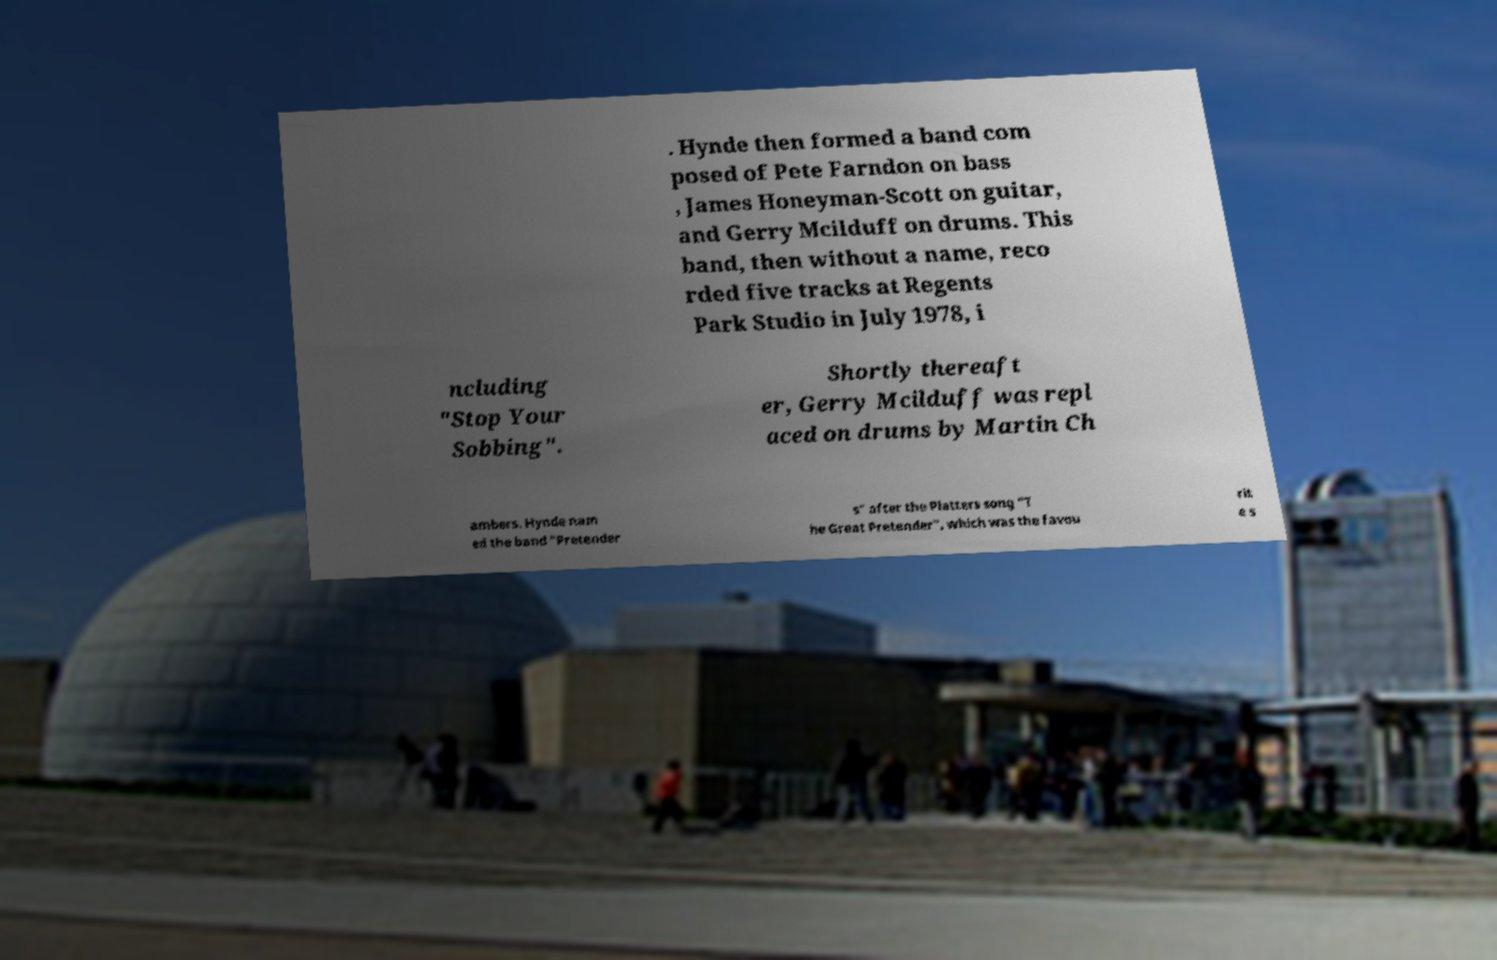There's text embedded in this image that I need extracted. Can you transcribe it verbatim? . Hynde then formed a band com posed of Pete Farndon on bass , James Honeyman-Scott on guitar, and Gerry Mcilduff on drums. This band, then without a name, reco rded five tracks at Regents Park Studio in July 1978, i ncluding "Stop Your Sobbing". Shortly thereaft er, Gerry Mcilduff was repl aced on drums by Martin Ch ambers. Hynde nam ed the band "Pretender s" after the Platters song "T he Great Pretender", which was the favou rit e s 